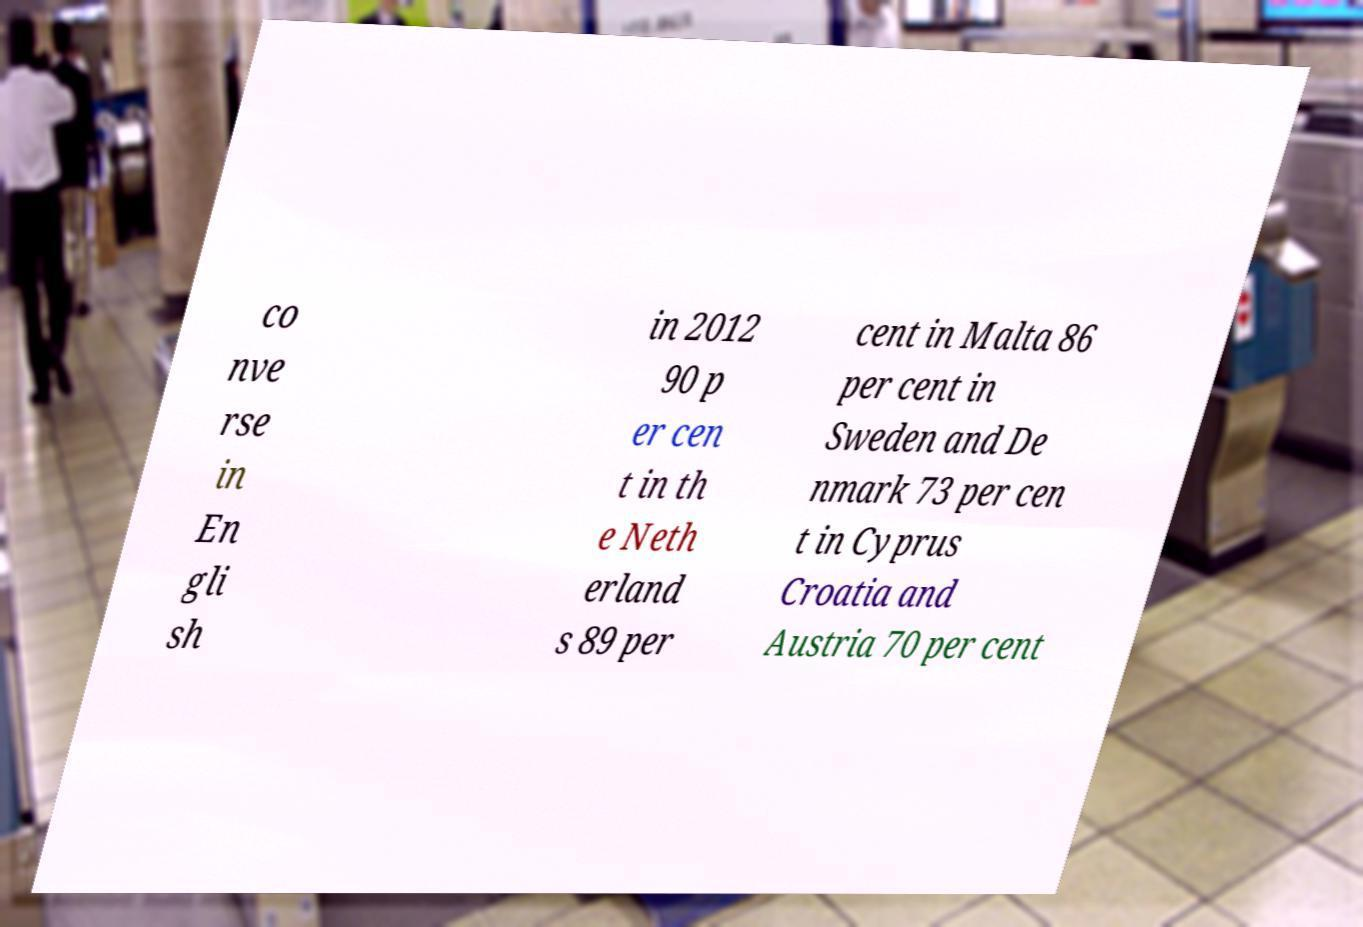Could you extract and type out the text from this image? co nve rse in En gli sh in 2012 90 p er cen t in th e Neth erland s 89 per cent in Malta 86 per cent in Sweden and De nmark 73 per cen t in Cyprus Croatia and Austria 70 per cent 